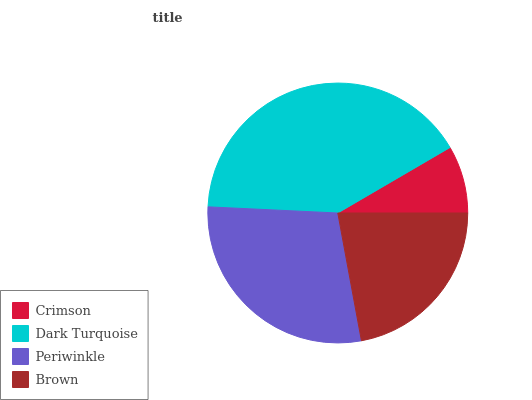Is Crimson the minimum?
Answer yes or no. Yes. Is Dark Turquoise the maximum?
Answer yes or no. Yes. Is Periwinkle the minimum?
Answer yes or no. No. Is Periwinkle the maximum?
Answer yes or no. No. Is Dark Turquoise greater than Periwinkle?
Answer yes or no. Yes. Is Periwinkle less than Dark Turquoise?
Answer yes or no. Yes. Is Periwinkle greater than Dark Turquoise?
Answer yes or no. No. Is Dark Turquoise less than Periwinkle?
Answer yes or no. No. Is Periwinkle the high median?
Answer yes or no. Yes. Is Brown the low median?
Answer yes or no. Yes. Is Crimson the high median?
Answer yes or no. No. Is Periwinkle the low median?
Answer yes or no. No. 